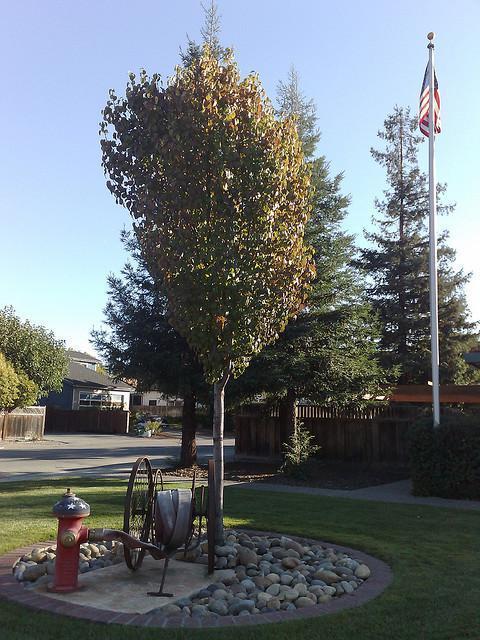How many people are wearing glasses?
Give a very brief answer. 0. 